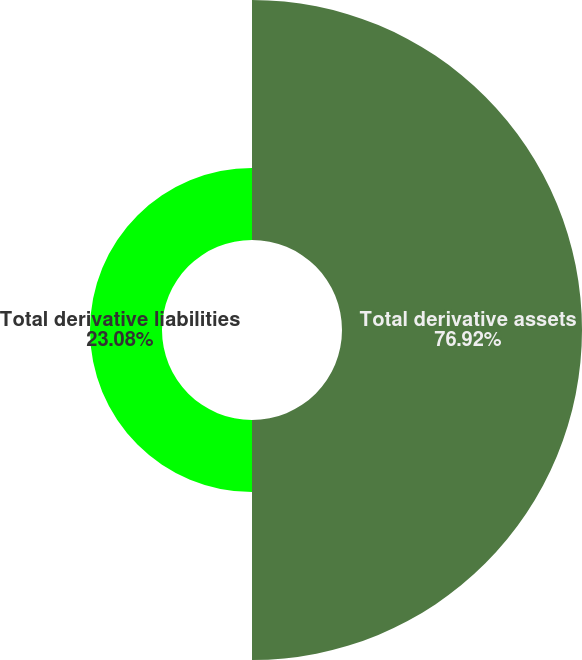<chart> <loc_0><loc_0><loc_500><loc_500><pie_chart><fcel>Total derivative assets<fcel>Total derivative liabilities<nl><fcel>76.92%<fcel>23.08%<nl></chart> 